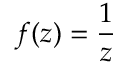Convert formula to latex. <formula><loc_0><loc_0><loc_500><loc_500>f ( z ) = { \frac { 1 } { z } }</formula> 